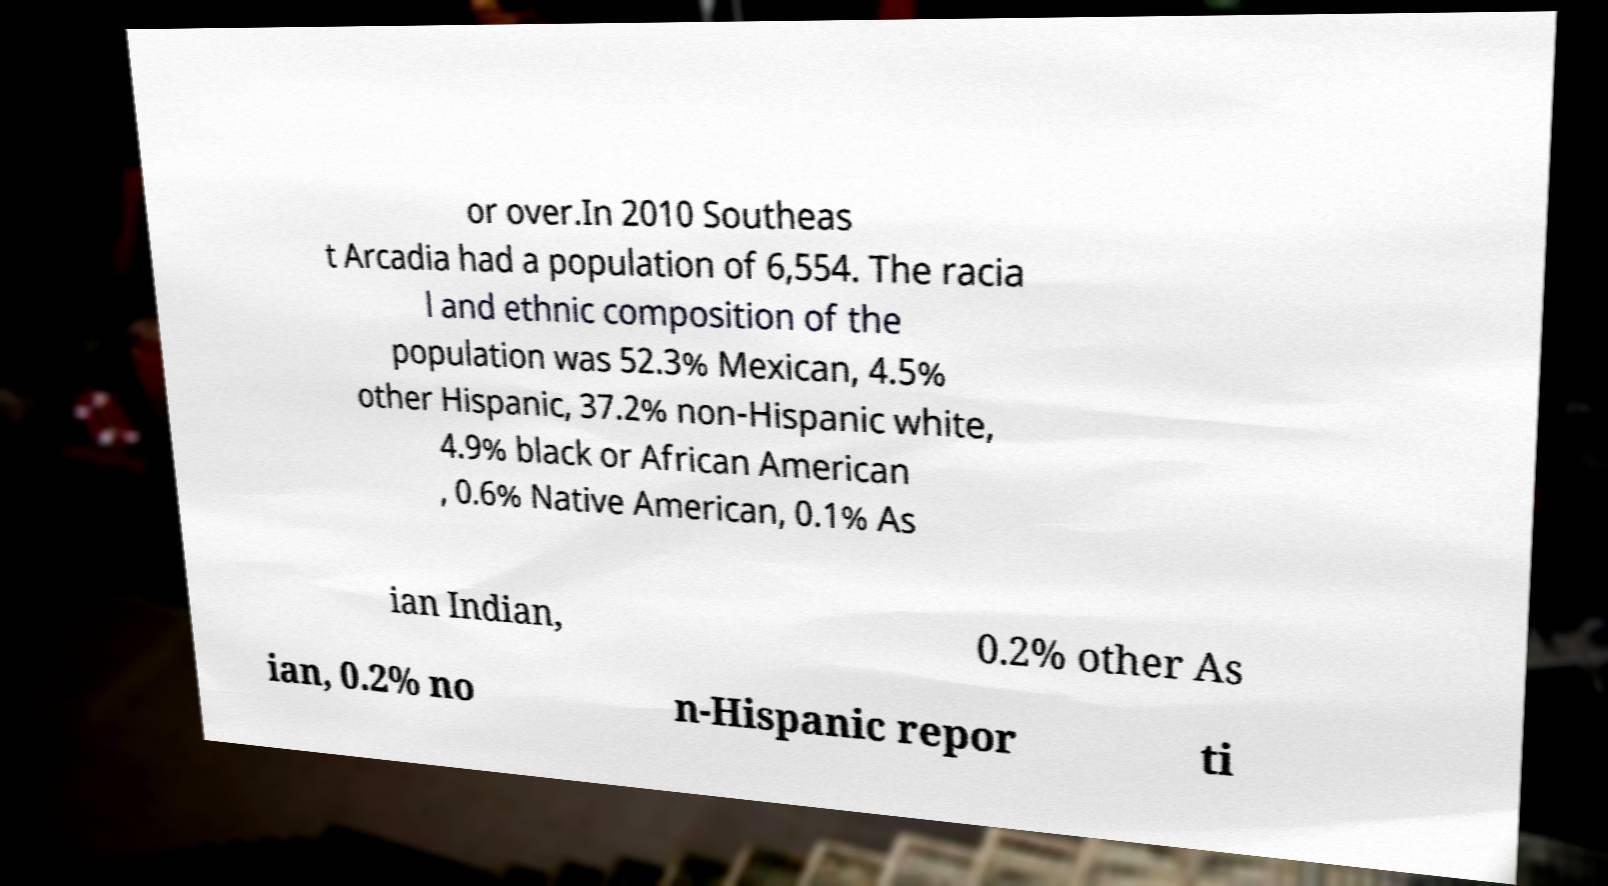Can you read and provide the text displayed in the image?This photo seems to have some interesting text. Can you extract and type it out for me? or over.In 2010 Southeas t Arcadia had a population of 6,554. The racia l and ethnic composition of the population was 52.3% Mexican, 4.5% other Hispanic, 37.2% non-Hispanic white, 4.9% black or African American , 0.6% Native American, 0.1% As ian Indian, 0.2% other As ian, 0.2% no n-Hispanic repor ti 